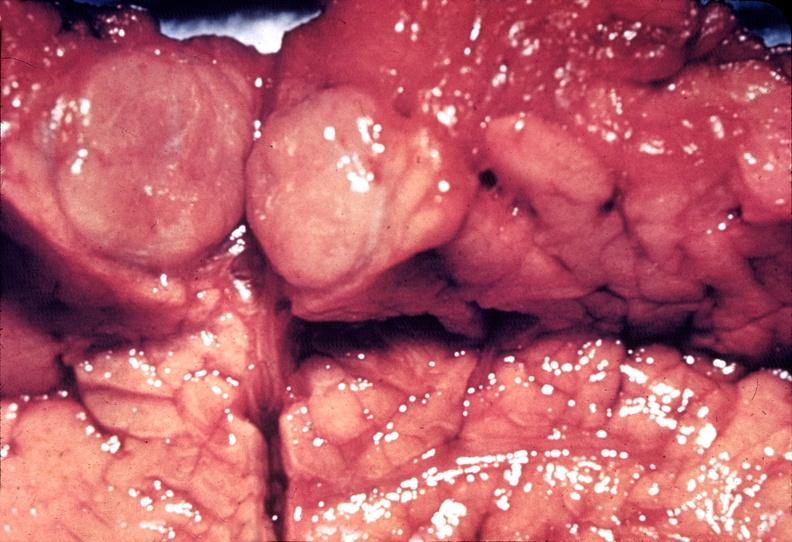what does this image show?
Answer the question using a single word or phrase. Islet cell carcinoma 